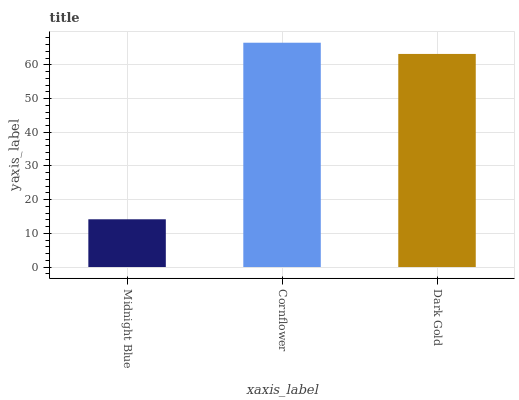Is Midnight Blue the minimum?
Answer yes or no. Yes. Is Cornflower the maximum?
Answer yes or no. Yes. Is Dark Gold the minimum?
Answer yes or no. No. Is Dark Gold the maximum?
Answer yes or no. No. Is Cornflower greater than Dark Gold?
Answer yes or no. Yes. Is Dark Gold less than Cornflower?
Answer yes or no. Yes. Is Dark Gold greater than Cornflower?
Answer yes or no. No. Is Cornflower less than Dark Gold?
Answer yes or no. No. Is Dark Gold the high median?
Answer yes or no. Yes. Is Dark Gold the low median?
Answer yes or no. Yes. Is Cornflower the high median?
Answer yes or no. No. Is Midnight Blue the low median?
Answer yes or no. No. 